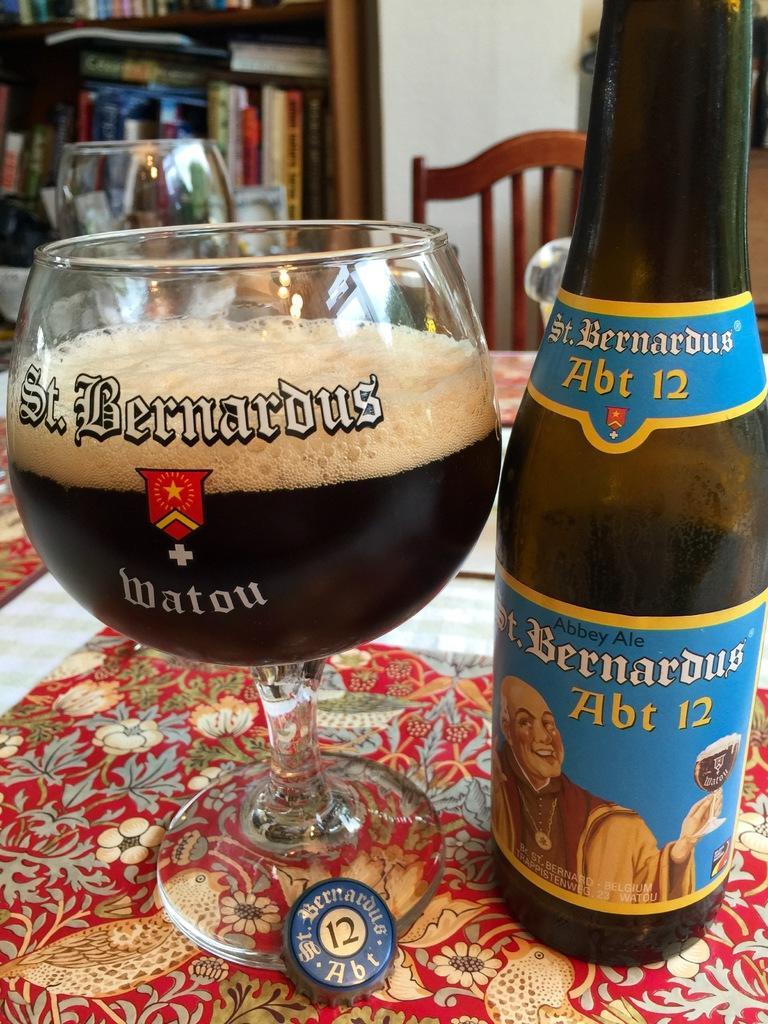Can you describe this image briefly? This is a wine glass and a bottle with a metal cap placed on the table. This is table is covered with cloth. At background I can see books placed in the bookshelf. This looks like a chair. 